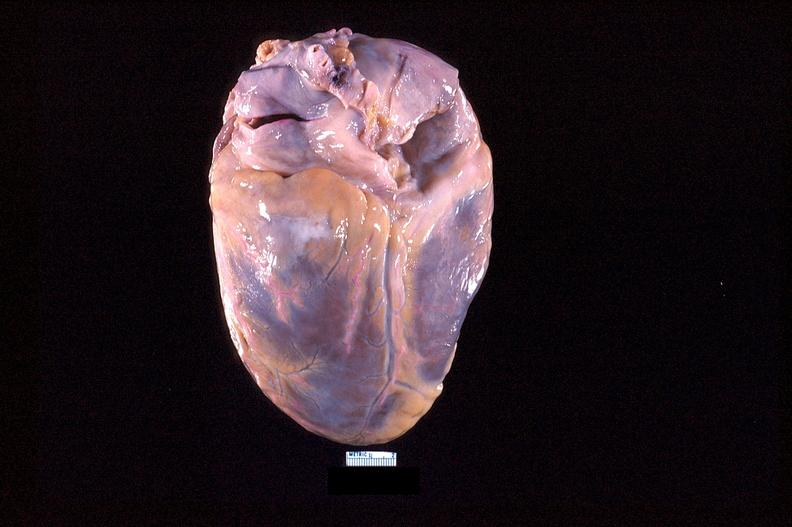where is this?
Answer the question using a single word or phrase. Heart 